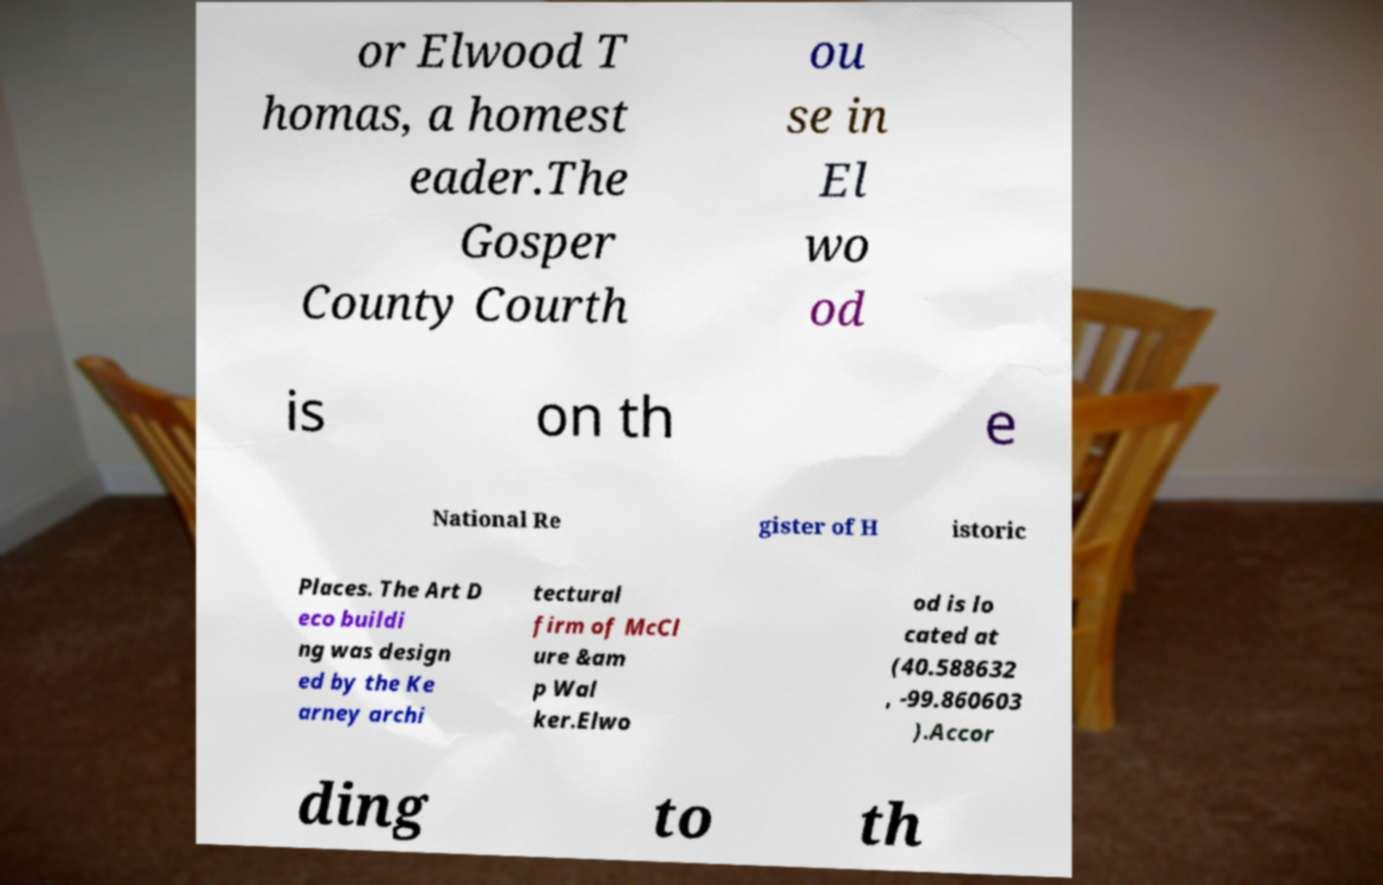Could you extract and type out the text from this image? or Elwood T homas, a homest eader.The Gosper County Courth ou se in El wo od is on th e National Re gister of H istoric Places. The Art D eco buildi ng was design ed by the Ke arney archi tectural firm of McCl ure &am p Wal ker.Elwo od is lo cated at (40.588632 , -99.860603 ).Accor ding to th 